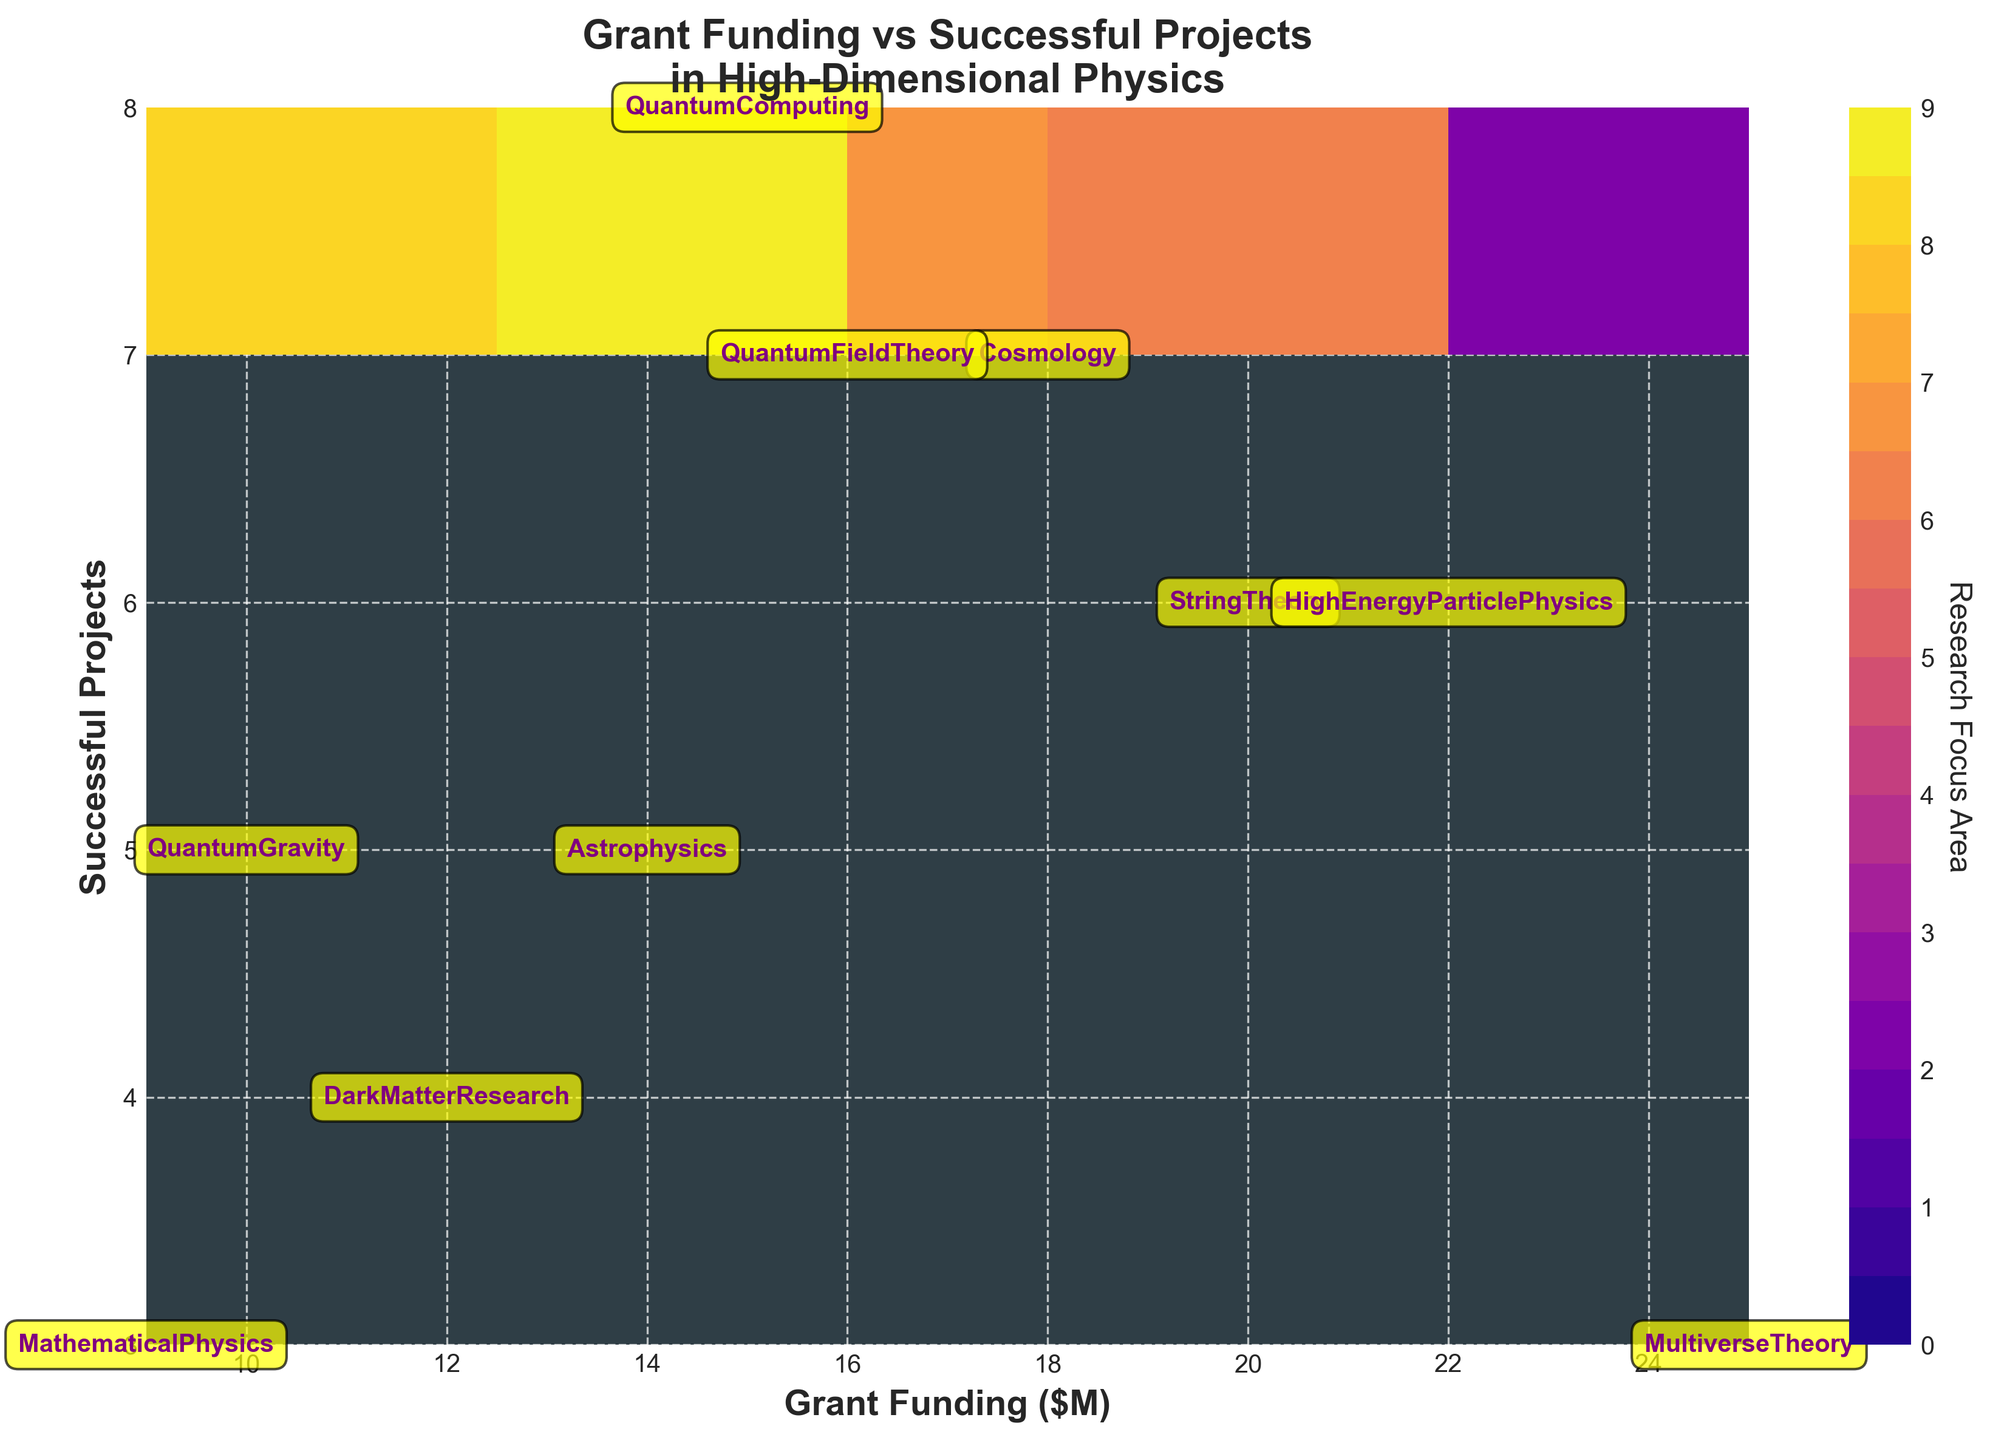Where does the title of the figure appear? The title is located at the top center of the figure and reads "Grant Funding vs Successful Projects\nin High-Dimensional Physics".
Answer: The top center of the figure What do the x and y axes represent in the figure? The x axis represents "Grant Funding ($M)", and the y axis represents "Successful Projects". These labels are noted alongside their respective axes with font size 14 and bold weight for clarity.
Answer: Grant Funding ($M) and Successful Projects Which research focus area received the highest grant funding? By examining the contour plot, it is evident that "Multiverse Theory" received the highest grant funding at $25M. This is annotated on the plot with yellow background and purple text.
Answer: Multiverse Theory Which research focus area had the most successful projects? Observing the contour plot, "Quantum Computing" had the most successful projects, totaling 8. This is indicated by the annotated labels on the plot.
Answer: Quantum Computing Which research areas have an equal number of successful projects? "String Theory" and "High Energy Particle Physics" both have 6 successful projects each, as indicated by their respective annotations on the plot.
Answer: String Theory and High Energy Particle Physics What is the relationship between grant funding and successful projects for "Mathematical Physics"? For "Mathematical Physics", the grant funding is $9M, and the successful projects are 3. This information is directly taken from the annotated labels at the corresponding contour plot position.
Answer: $9M and 3 Compare the grant funding received by "Cosmology" to "Astrophysics". Which one received more funding? According to the annotations, "Cosmology" received $18M, whereas "Astrophysics" received $14M. Thus, "Cosmology" received $4M more than "Astrophysics".
Answer: Cosmology Explain the distribution of successful projects in "Quantum Field Theory" compared to "Quantum Gravity". "Quantum Field Theory" has 7 successful projects while "Quantum Gravity" has 5. The difference is calculated by subtracting 5 from 7, which results in 2 additional successful projects for "Quantum Field Theory".
Answer: Quantum Field Theory has 2 more successful projects What does the color bar representing 'Research Focus Area' signify, and where is it located? The color bar, labeled 'Research Focus Area', enhances the contour plot by providing a visual guide to the values associated with different research areas. It is positioned on the right side of the plot, with its label oriented vertically.
Answer: Right side of the plot Which research focus area is located at the position (15,8) on the plot? The annotation at position (15,8) identifies "Quantum Computing", indicating it received $15M in funding and had 8 successful projects. This is derived directly from the plot annotation.
Answer: Quantum Computing 